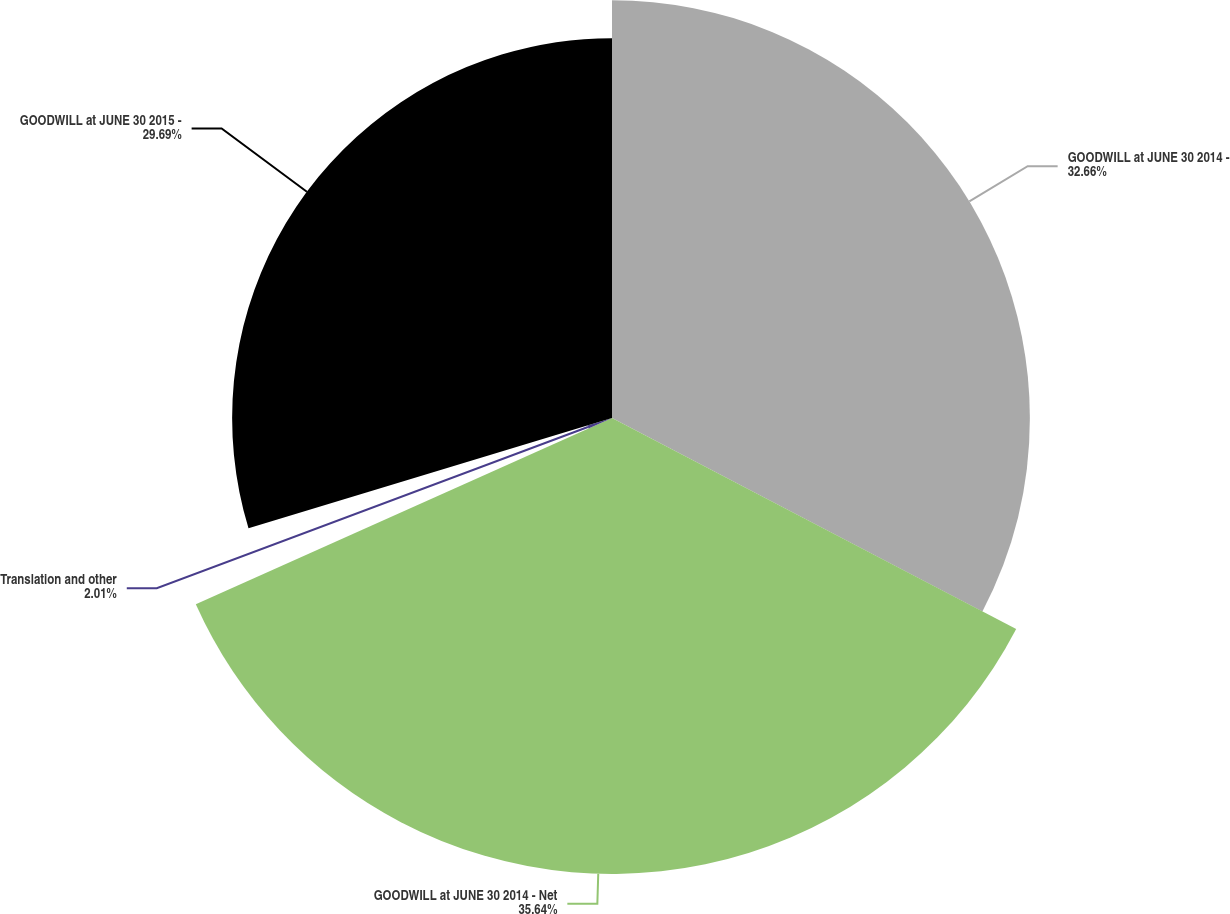Convert chart to OTSL. <chart><loc_0><loc_0><loc_500><loc_500><pie_chart><fcel>GOODWILL at JUNE 30 2014 -<fcel>GOODWILL at JUNE 30 2014 - Net<fcel>Translation and other<fcel>GOODWILL at JUNE 30 2015 -<nl><fcel>32.66%<fcel>35.64%<fcel>2.01%<fcel>29.69%<nl></chart> 